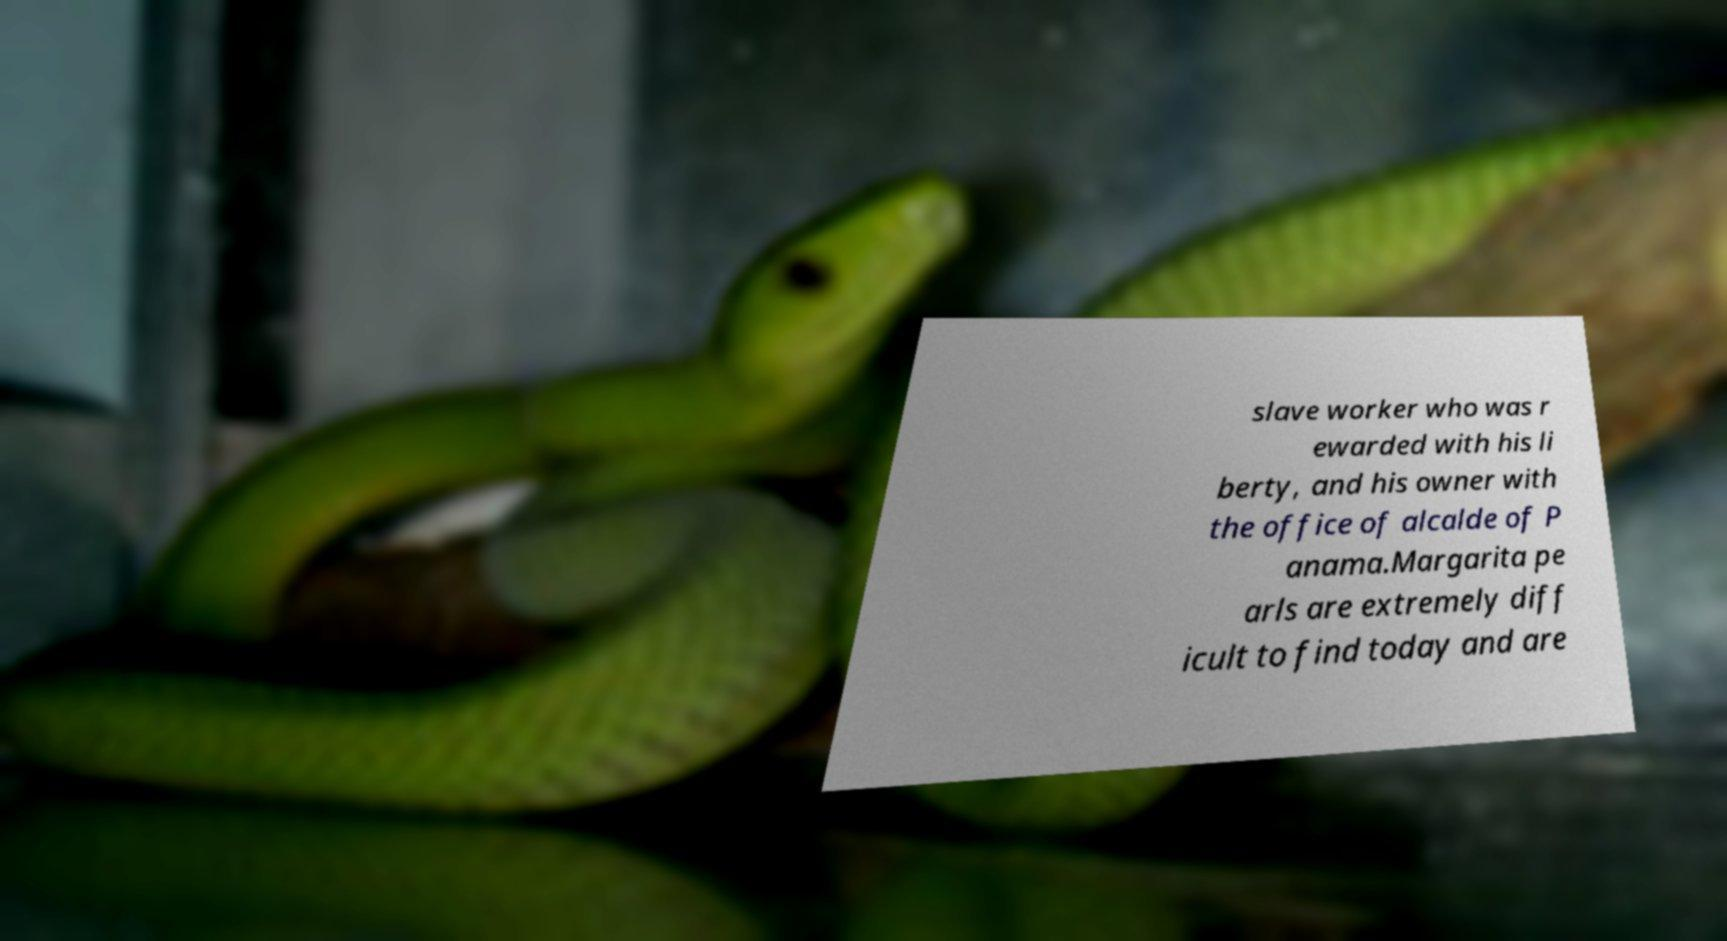I need the written content from this picture converted into text. Can you do that? slave worker who was r ewarded with his li berty, and his owner with the office of alcalde of P anama.Margarita pe arls are extremely diff icult to find today and are 